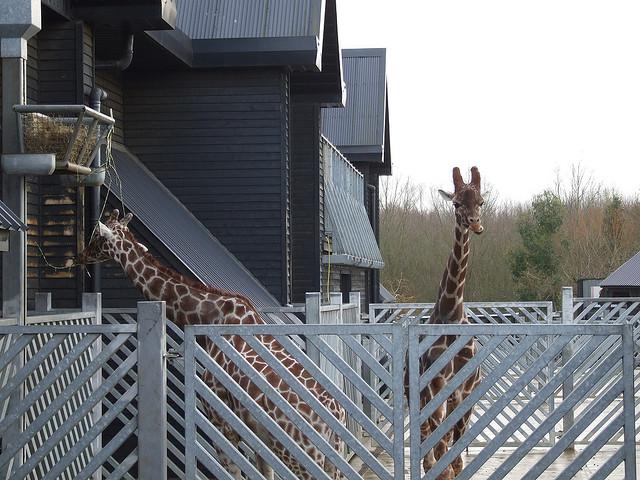What is the giraffe looking at?
Be succinct. Camera. What type of animal is on the fence?
Write a very short answer. Giraffe. What color is the fence?
Answer briefly. White. 